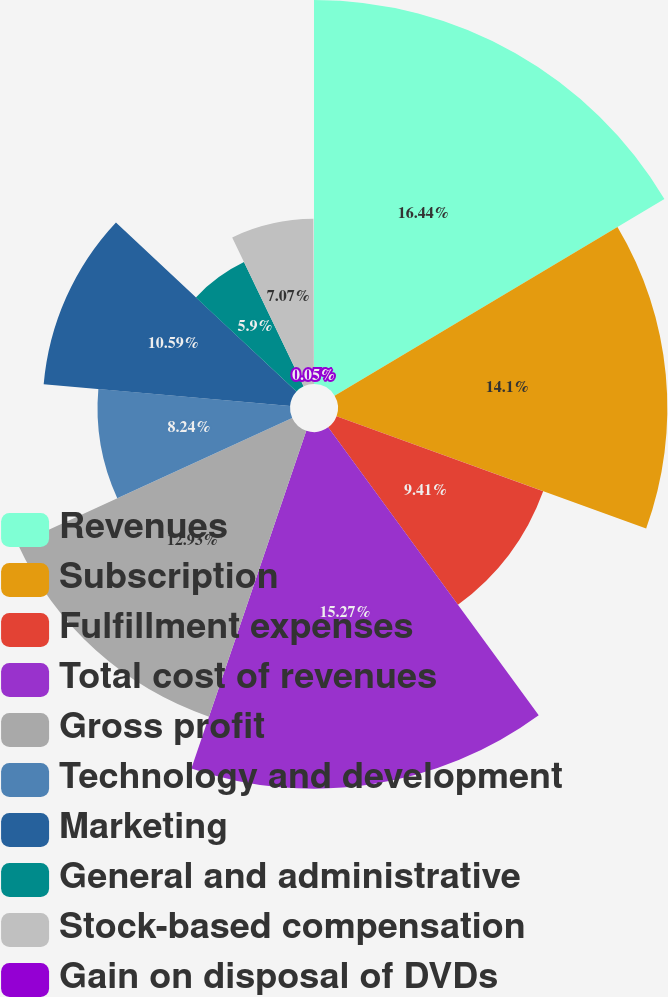Convert chart to OTSL. <chart><loc_0><loc_0><loc_500><loc_500><pie_chart><fcel>Revenues<fcel>Subscription<fcel>Fulfillment expenses<fcel>Total cost of revenues<fcel>Gross profit<fcel>Technology and development<fcel>Marketing<fcel>General and administrative<fcel>Stock-based compensation<fcel>Gain on disposal of DVDs<nl><fcel>16.44%<fcel>14.1%<fcel>9.41%<fcel>15.27%<fcel>12.93%<fcel>8.24%<fcel>10.59%<fcel>5.9%<fcel>7.07%<fcel>0.05%<nl></chart> 